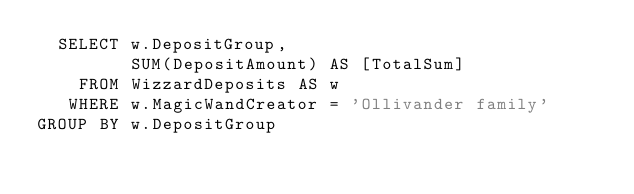<code> <loc_0><loc_0><loc_500><loc_500><_SQL_>  SELECT w.DepositGroup,
         SUM(DepositAmount) AS [TotalSum]
    FROM WizzardDeposits AS w
   WHERE w.MagicWandCreator = 'Ollivander family'
GROUP BY w.DepositGroup
</code> 